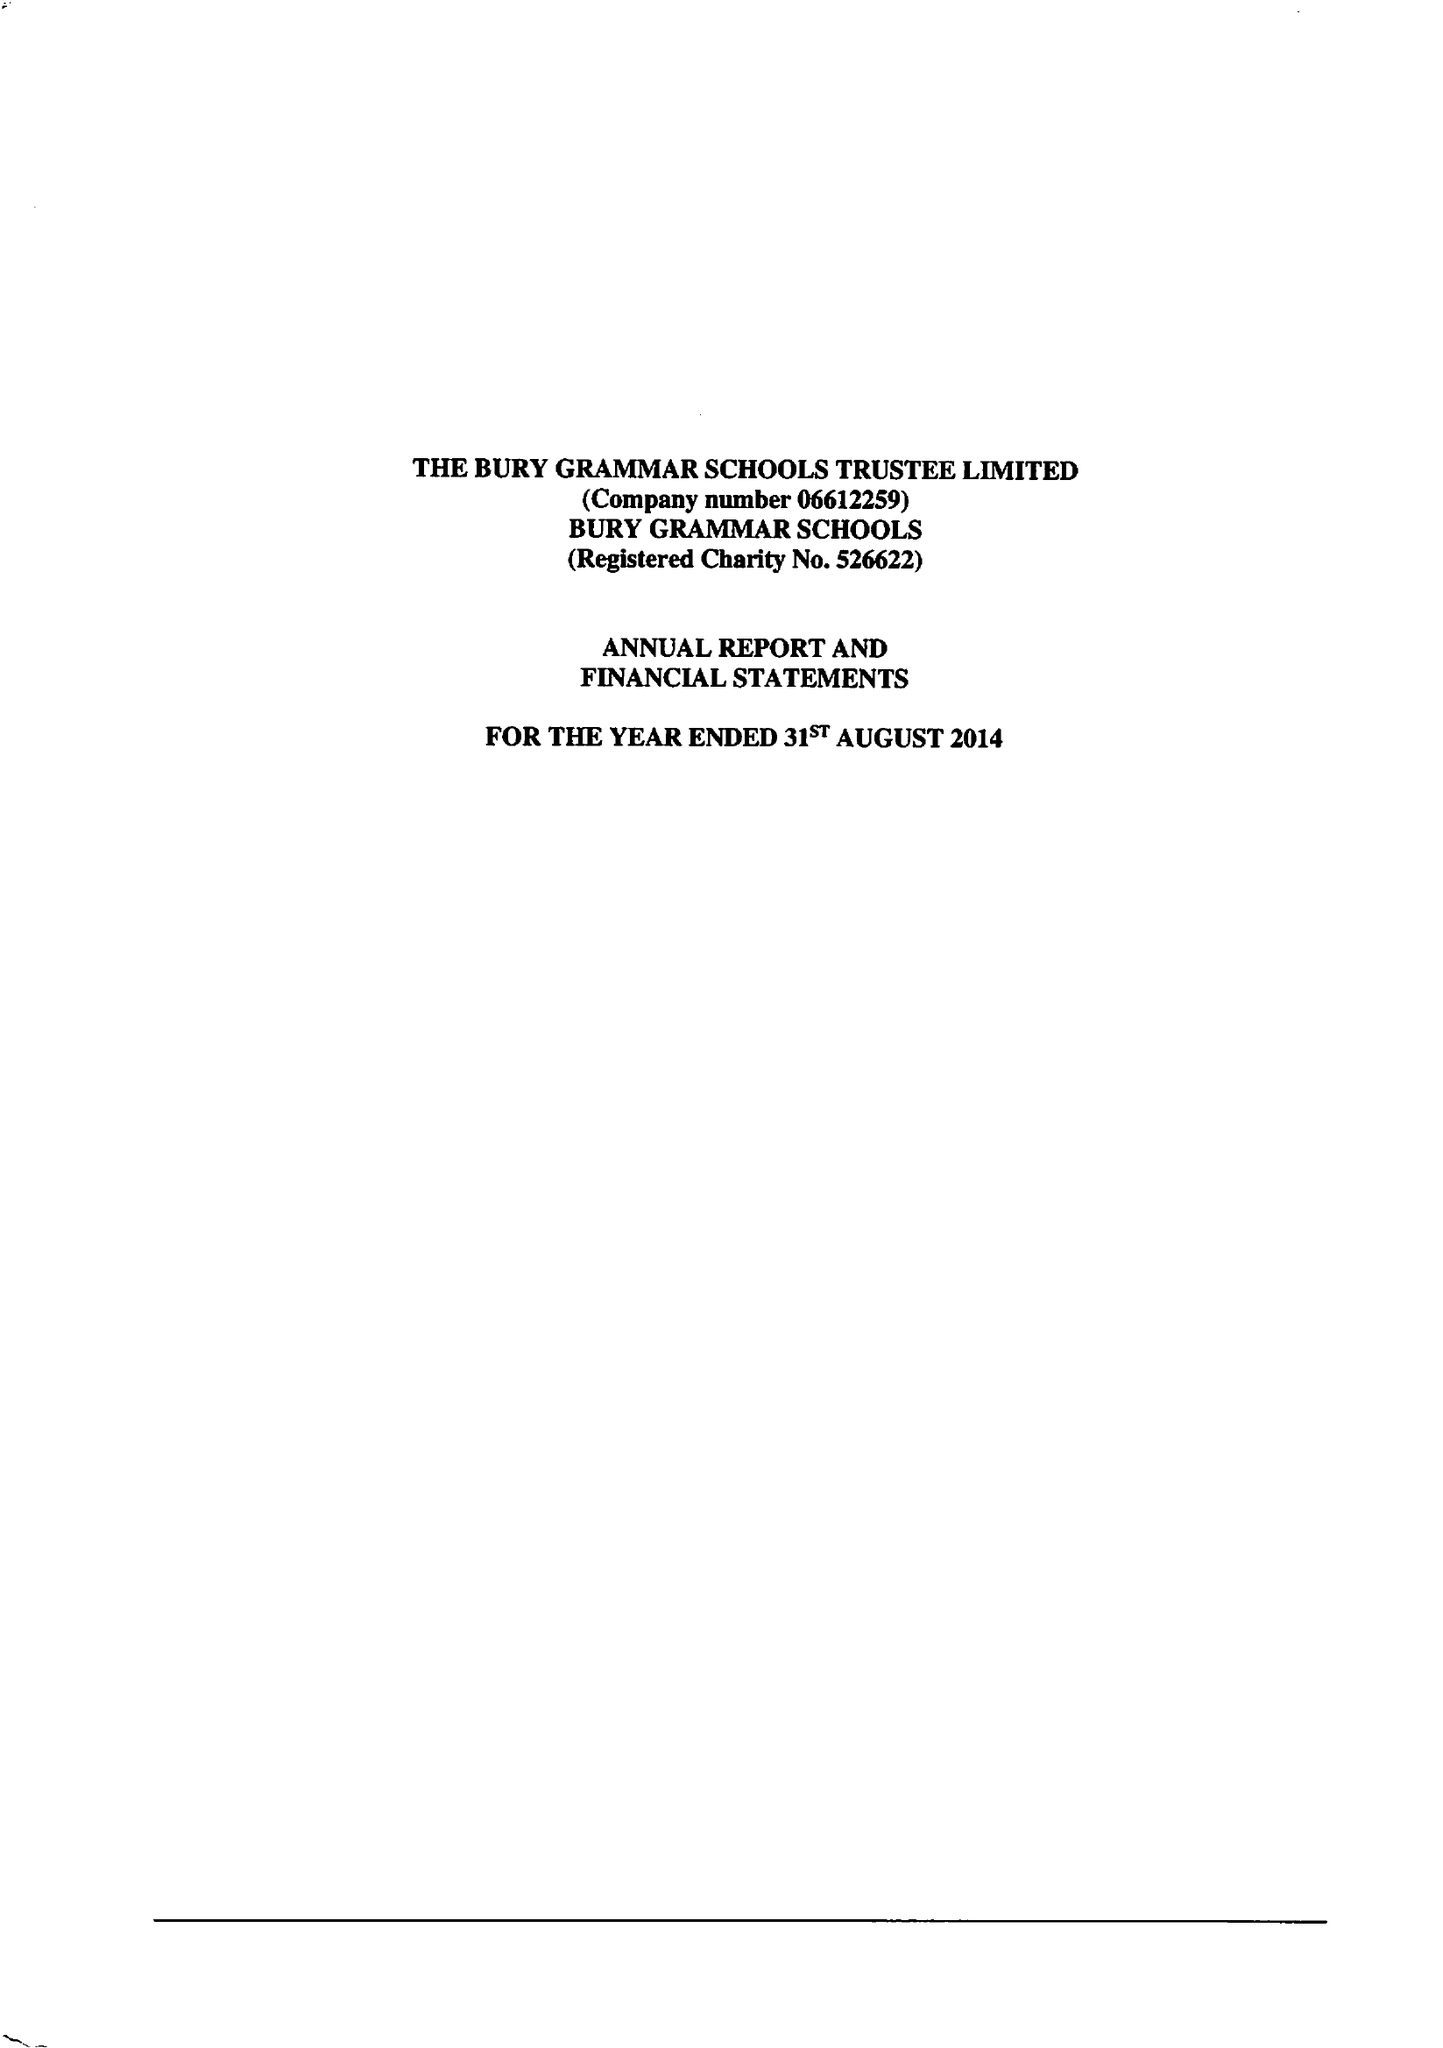What is the value for the address__post_town?
Answer the question using a single word or phrase. BURY 